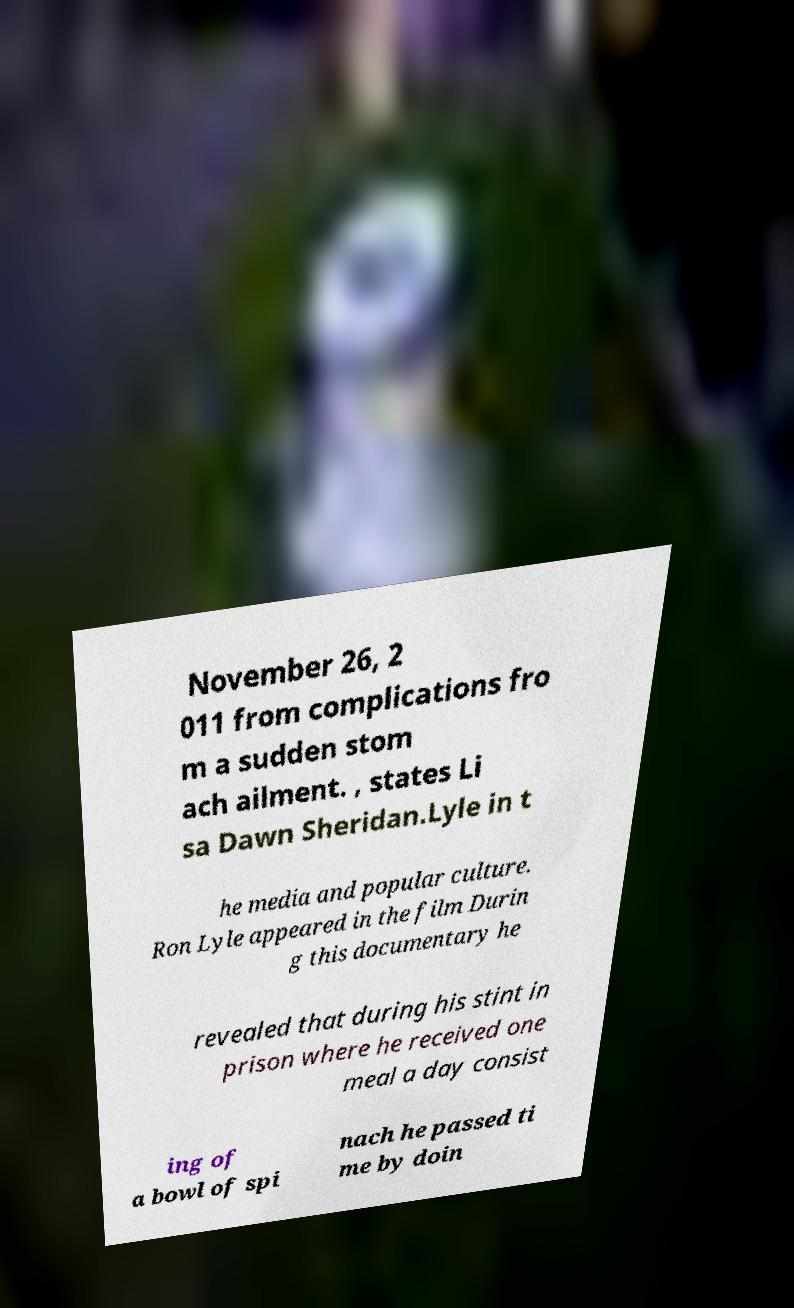Please identify and transcribe the text found in this image. November 26, 2 011 from complications fro m a sudden stom ach ailment. , states Li sa Dawn Sheridan.Lyle in t he media and popular culture. Ron Lyle appeared in the film Durin g this documentary he revealed that during his stint in prison where he received one meal a day consist ing of a bowl of spi nach he passed ti me by doin 